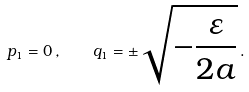<formula> <loc_0><loc_0><loc_500><loc_500>p _ { 1 } = 0 \, , \quad q _ { 1 } = \pm \sqrt { - \frac { \varepsilon } { 2 a } } \, .</formula> 